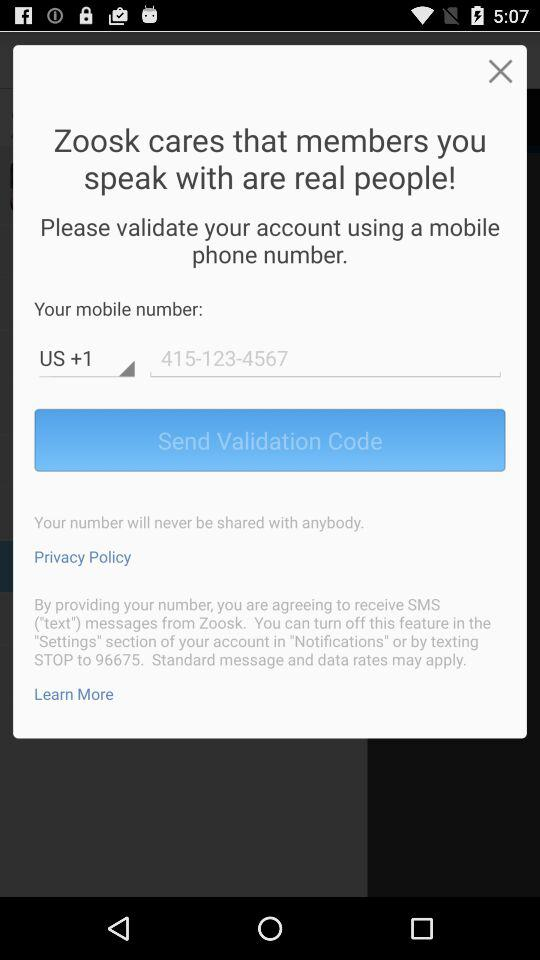What is the phone number? The phone number is +415-123-4567. 